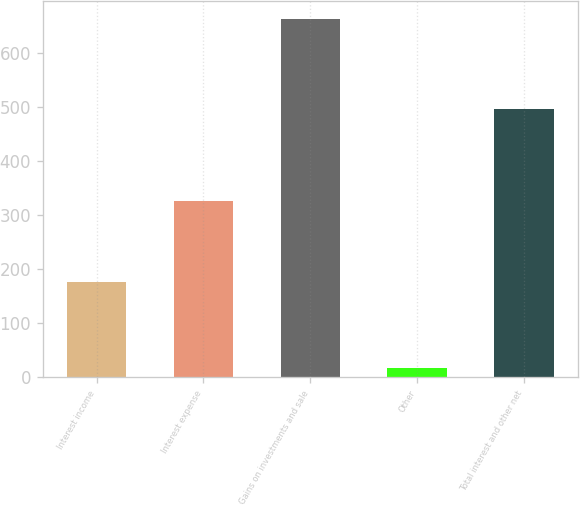Convert chart to OTSL. <chart><loc_0><loc_0><loc_500><loc_500><bar_chart><fcel>Interest income<fcel>Interest expense<fcel>Gains on investments and sale<fcel>Other<fcel>Total interest and other net<nl><fcel>176<fcel>326<fcel>663<fcel>17<fcel>496<nl></chart> 